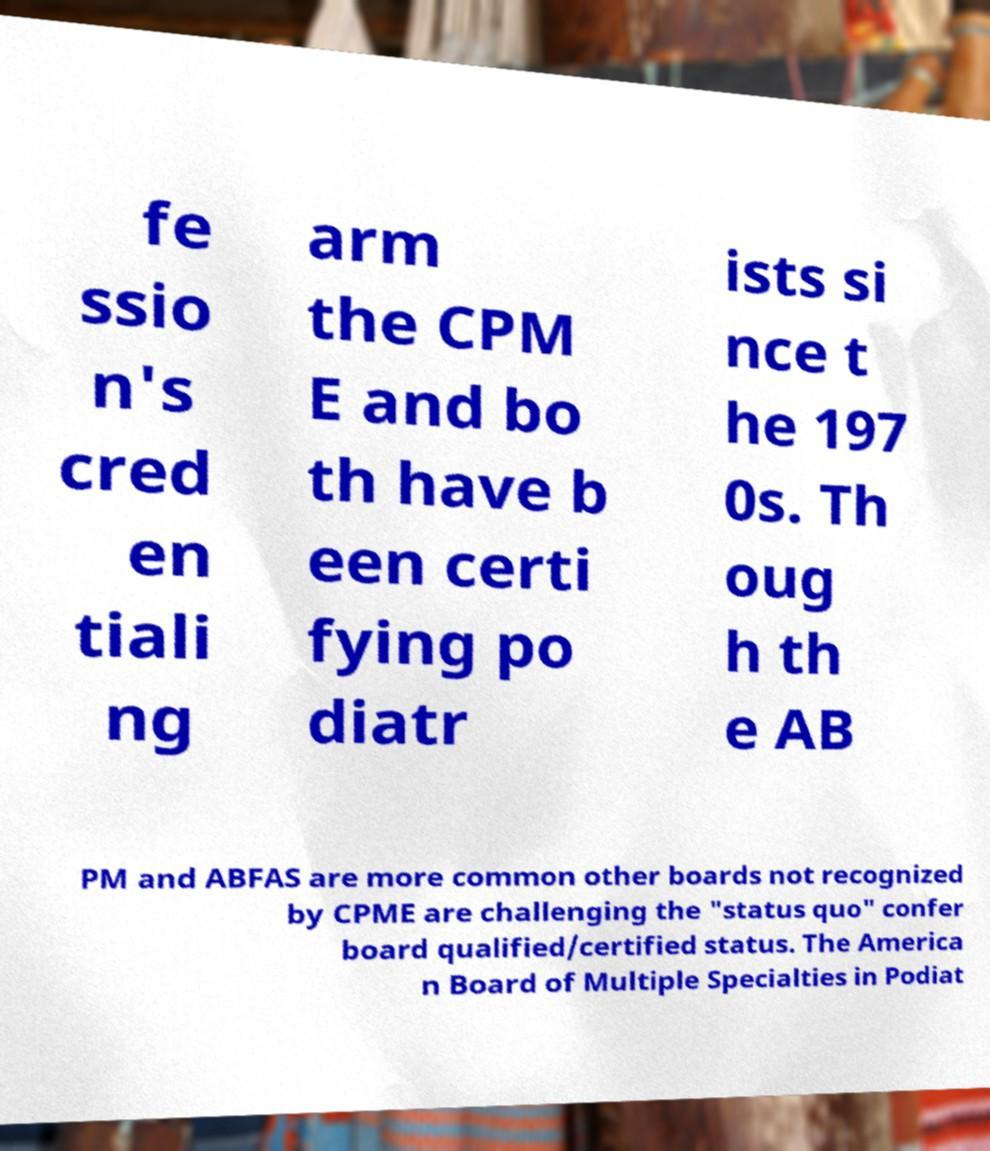What messages or text are displayed in this image? I need them in a readable, typed format. fe ssio n's cred en tiali ng arm the CPM E and bo th have b een certi fying po diatr ists si nce t he 197 0s. Th oug h th e AB PM and ABFAS are more common other boards not recognized by CPME are challenging the "status quo" confer board qualified/certified status. The America n Board of Multiple Specialties in Podiat 